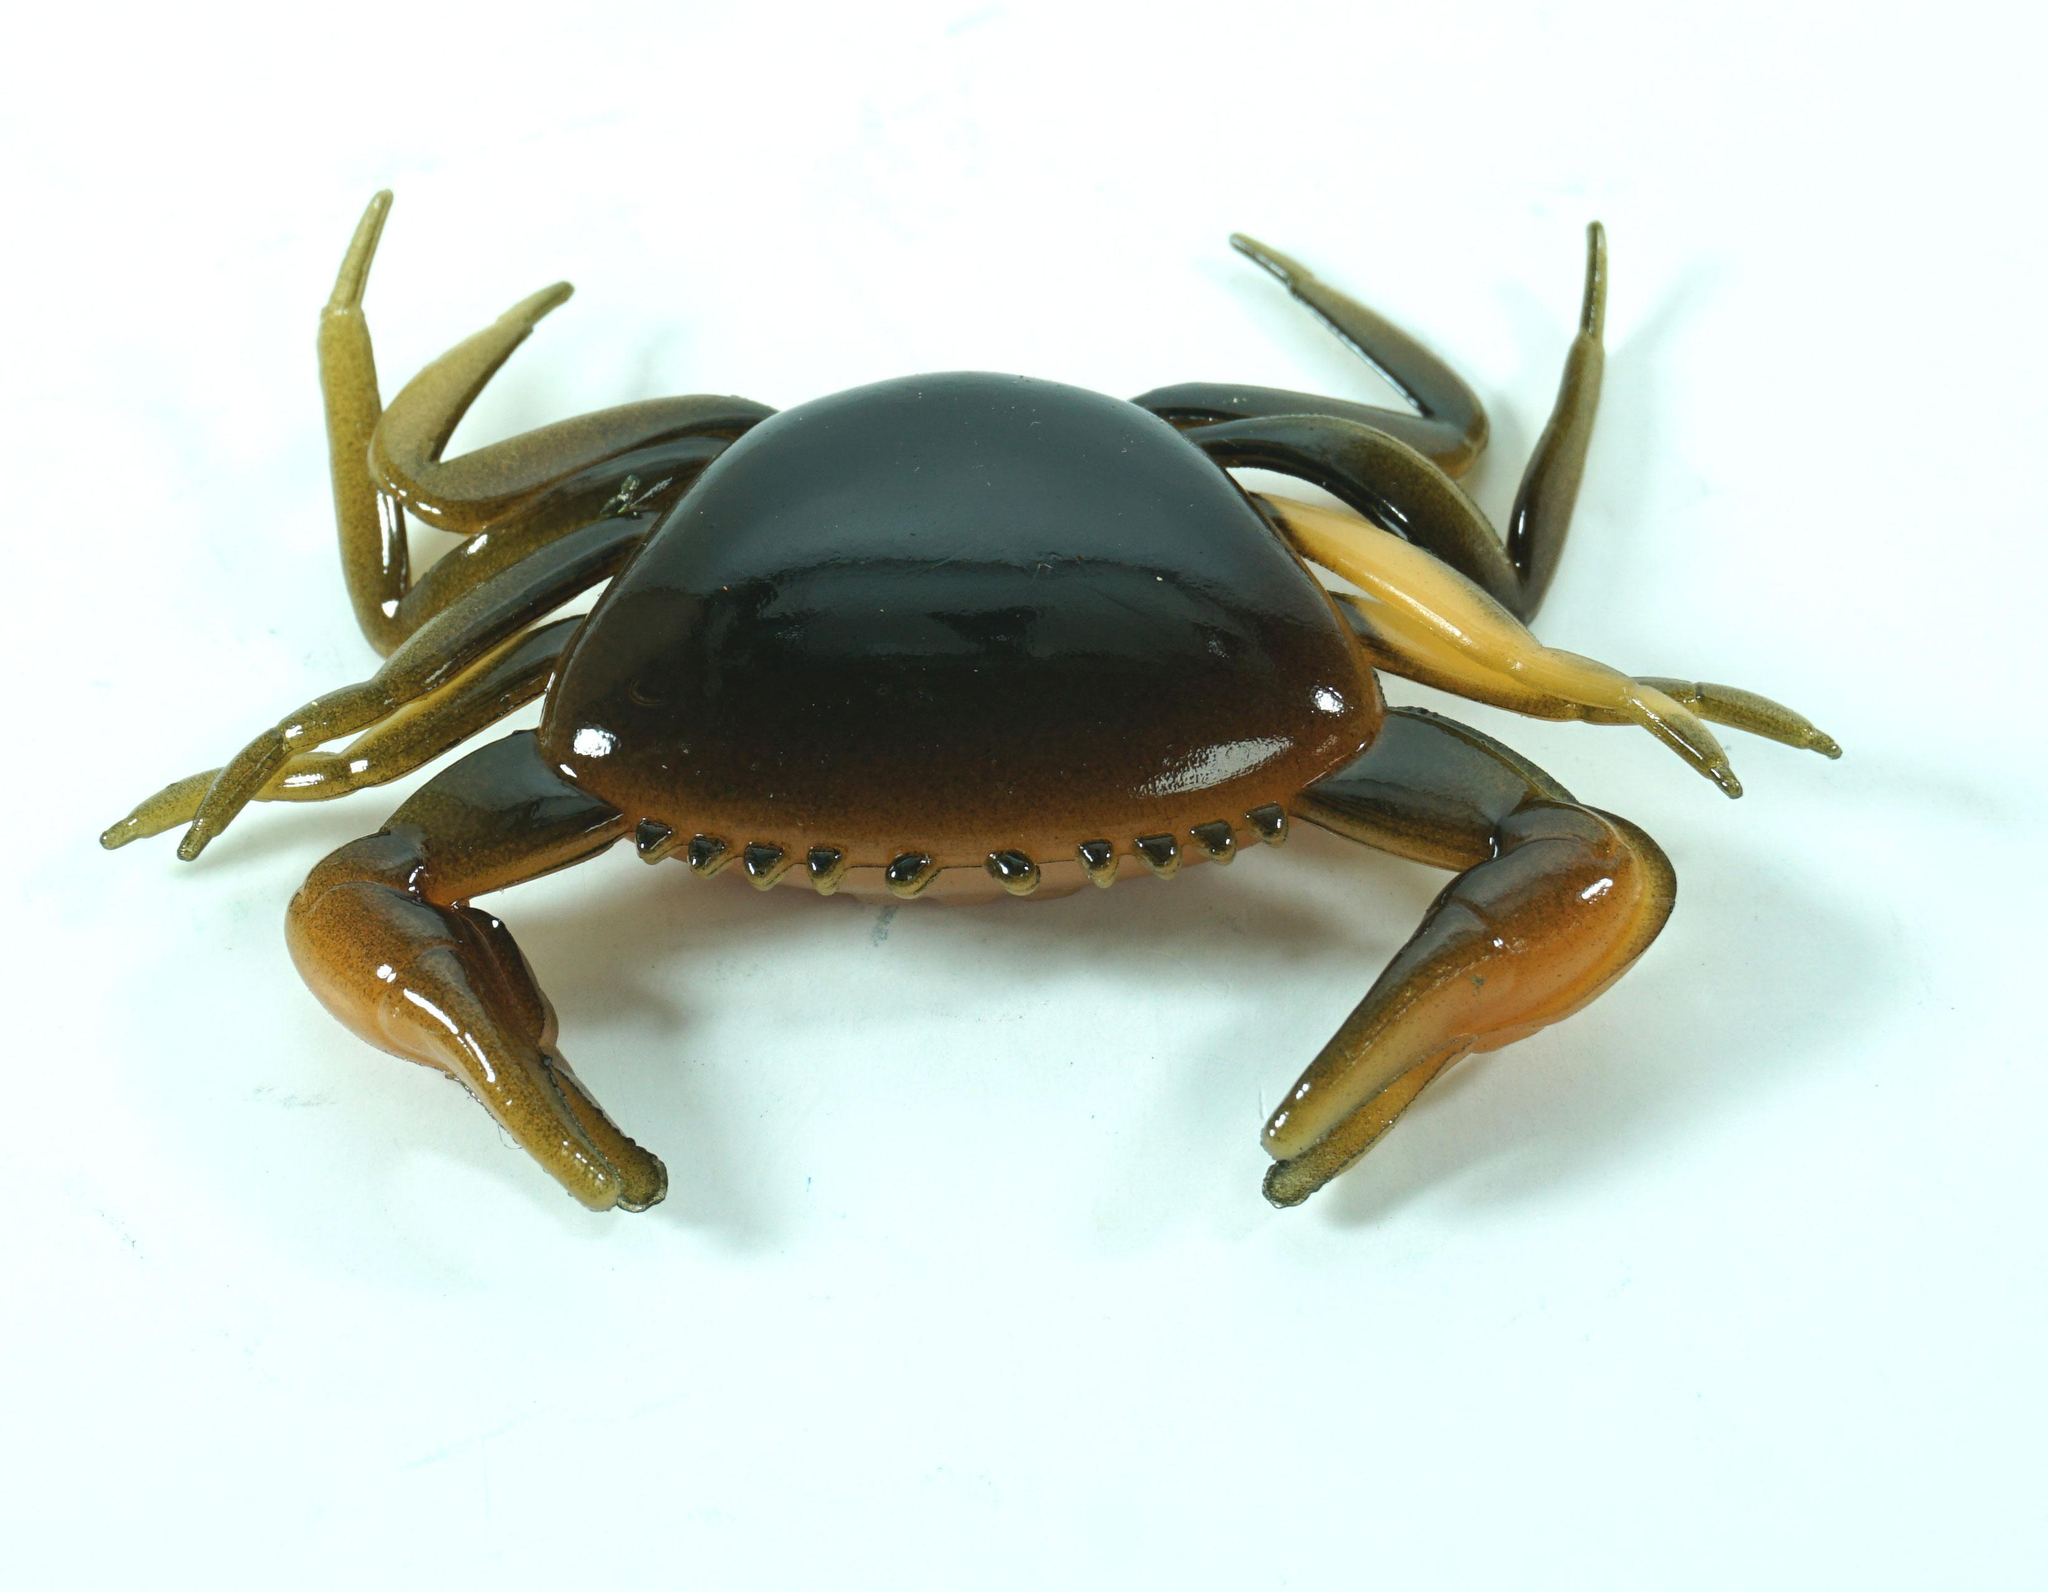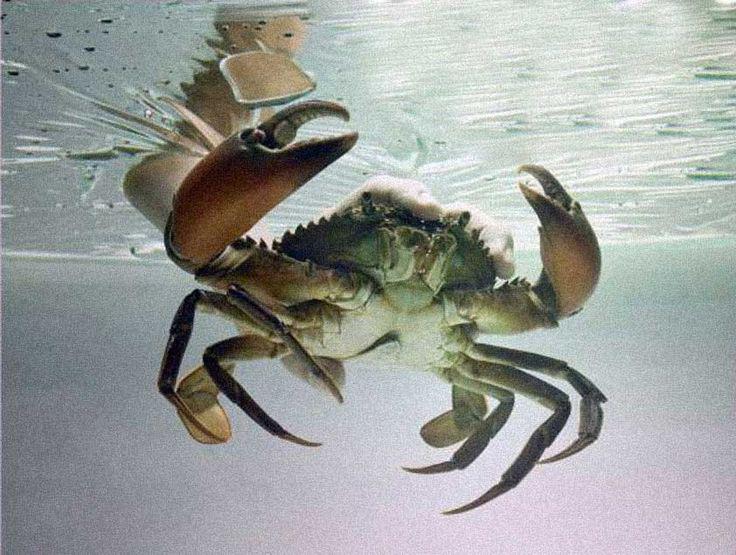The first image is the image on the left, the second image is the image on the right. For the images displayed, is the sentence "The left image contains one forward-facing crab with its front claws somewhat extended and its top shell visible." factually correct? Answer yes or no. Yes. The first image is the image on the left, the second image is the image on the right. For the images shown, is this caption "The left and right image contains two shelled crabs." true? Answer yes or no. Yes. 